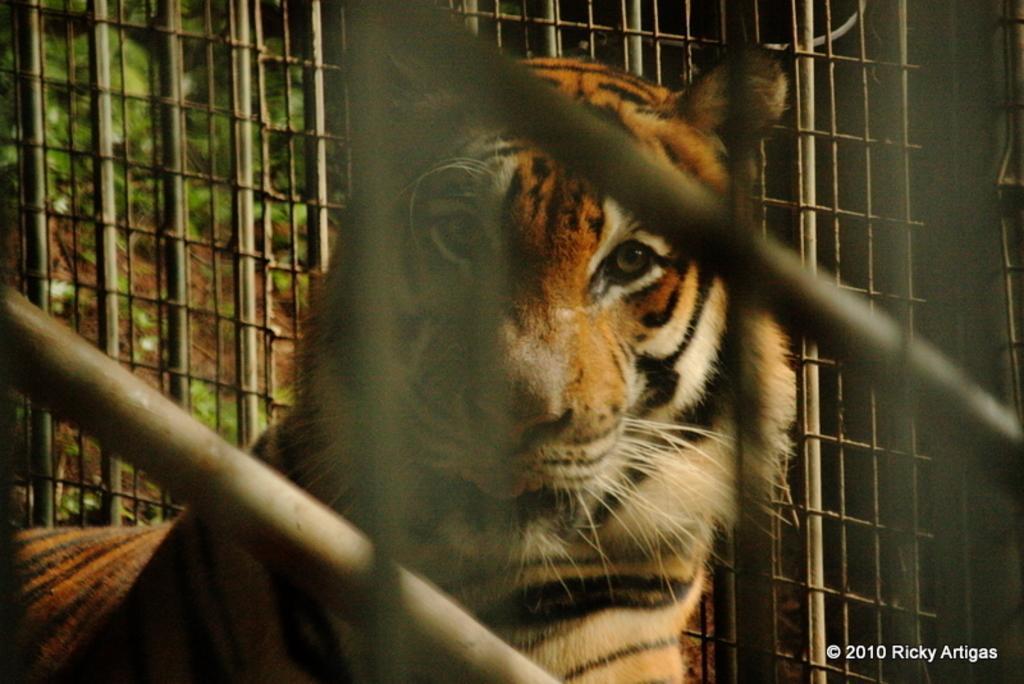In one or two sentences, can you explain what this image depicts? In the i can see a animal and behind that i can see a window and trees. 